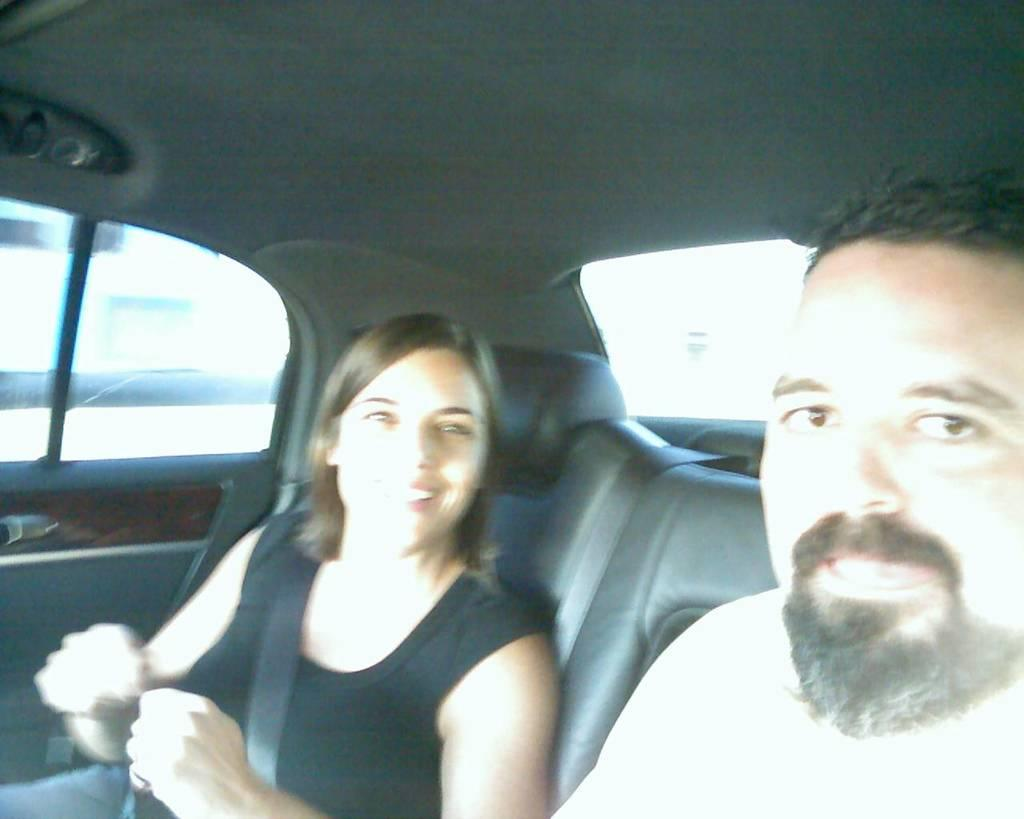Who is present in the image? There is a man and a woman in the image. What is the setting of the image? Both the man and woman are inside a car. Is the woman taking any safety precautions in the image? Yes, the woman is wearing a seatbelt. What is the woman's expression in the image? The woman is smiling. What type of box is the woman teaching in the image? There is no box or teaching activity present in the image. 